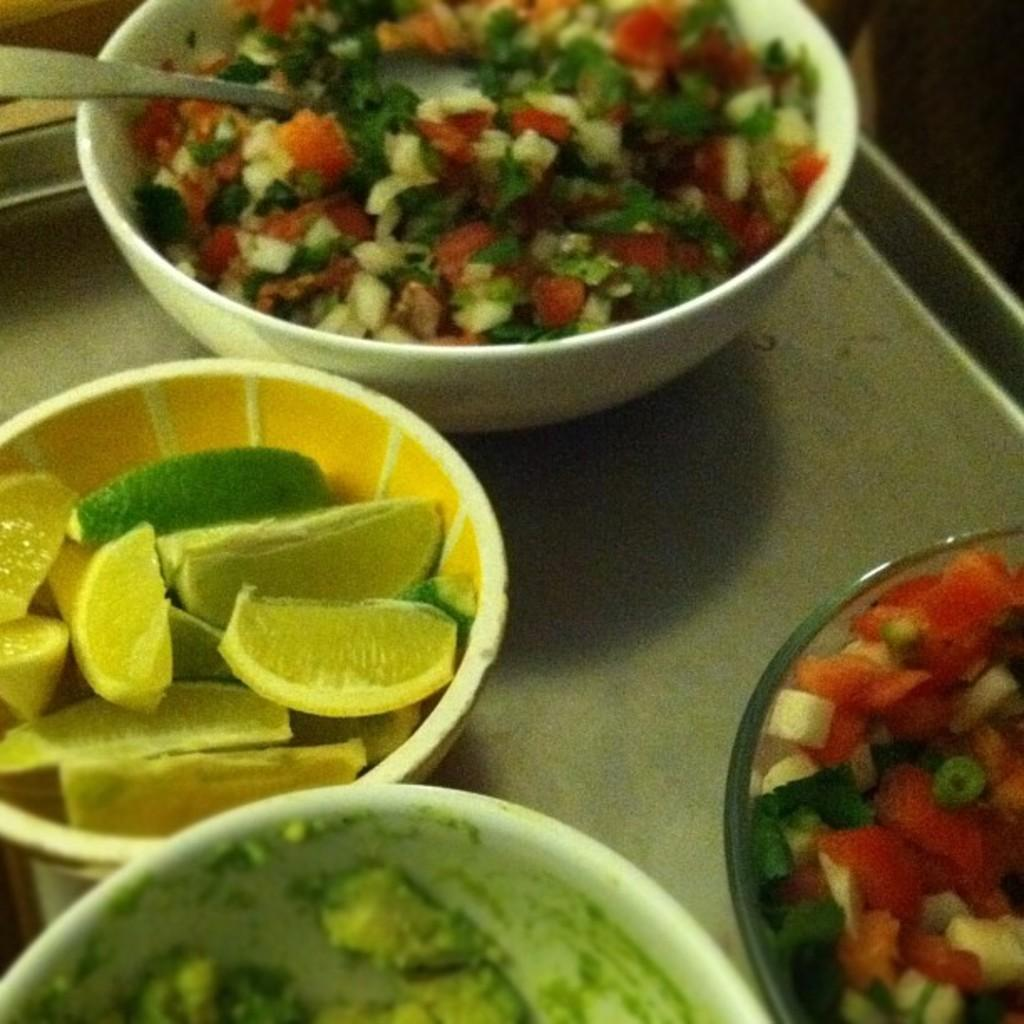What is in the bowl located in the foreground of the image? There are cut vegetables in a bowl in the foreground of the image. What utensil is associated with the bowl of cut vegetables? There is a spoon associated with the bowl of cut vegetables. What else can be seen in the foreground of the image? There is another bowl with orange pieces in a tray in the foreground of the image. What type of clouds can be seen in the image? There are no clouds visible in the image; it features bowls of cut vegetables and orange pieces. What color is the ink used to write the recipe on the paper in the image? There is no paper or ink present in the image. 